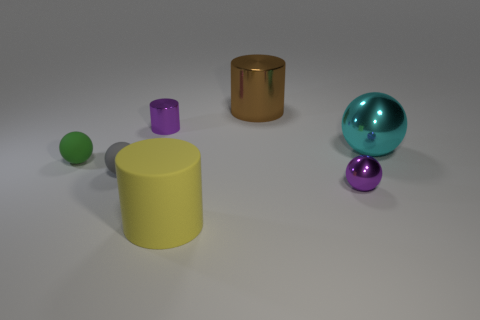Does the shiny thing that is to the left of the big yellow cylinder have the same color as the small ball that is right of the yellow matte cylinder?
Make the answer very short. Yes. Is there any other thing that is the same size as the cyan sphere?
Provide a short and direct response. Yes. Are there any green matte things to the right of the brown object?
Make the answer very short. No. How many small gray matte objects are the same shape as the brown shiny thing?
Provide a short and direct response. 0. What is the color of the large cylinder in front of the small thing that is right of the tiny metal thing to the left of the big metal cylinder?
Keep it short and to the point. Yellow. Are the purple thing that is behind the purple ball and the purple thing that is in front of the small green sphere made of the same material?
Your answer should be very brief. Yes. What number of things are either tiny purple shiny objects left of the brown shiny cylinder or small yellow metal objects?
Give a very brief answer. 1. How many objects are either cyan cylinders or small shiny objects that are to the right of the big yellow matte cylinder?
Your response must be concise. 1. How many gray things have the same size as the green thing?
Offer a terse response. 1. Is the number of small green rubber things that are on the left side of the brown object less than the number of small purple balls that are in front of the purple ball?
Offer a terse response. No. 